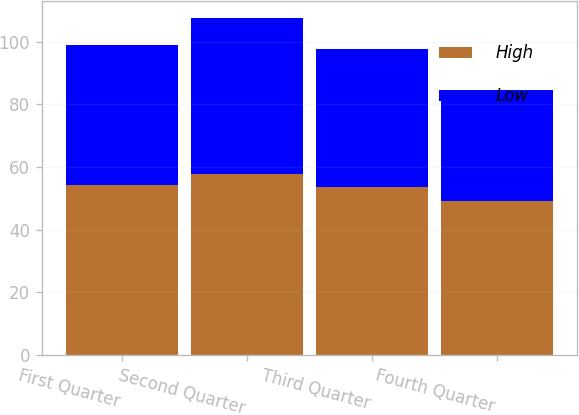<chart> <loc_0><loc_0><loc_500><loc_500><stacked_bar_chart><ecel><fcel>First Quarter<fcel>Second Quarter<fcel>Third Quarter<fcel>Fourth Quarter<nl><fcel>High<fcel>54.16<fcel>57.7<fcel>53.55<fcel>49.25<nl><fcel>Low<fcel>44.87<fcel>49.91<fcel>44.2<fcel>35.29<nl></chart> 